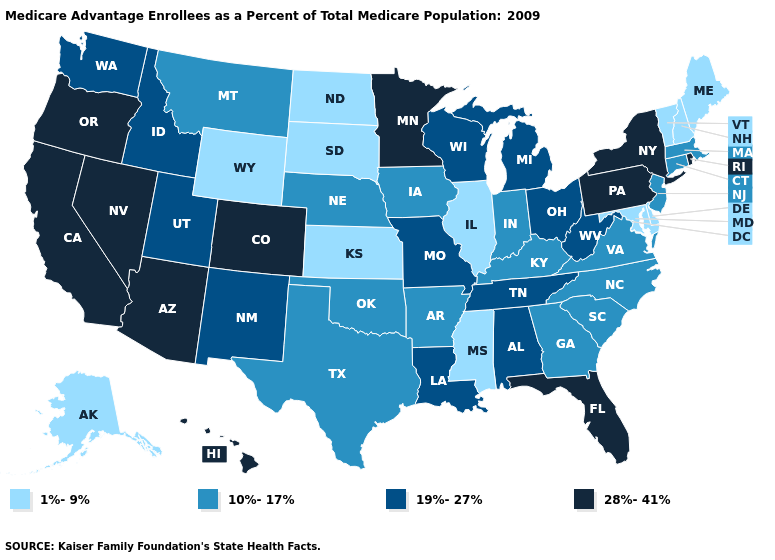Among the states that border Montana , does North Dakota have the lowest value?
Concise answer only. Yes. Is the legend a continuous bar?
Quick response, please. No. What is the lowest value in the South?
Concise answer only. 1%-9%. Among the states that border Alabama , which have the highest value?
Write a very short answer. Florida. What is the value of Indiana?
Concise answer only. 10%-17%. Which states have the highest value in the USA?
Concise answer only. Arizona, California, Colorado, Florida, Hawaii, Minnesota, Nevada, New York, Oregon, Pennsylvania, Rhode Island. What is the value of Maine?
Concise answer only. 1%-9%. Name the states that have a value in the range 10%-17%?
Concise answer only. Arkansas, Connecticut, Georgia, Iowa, Indiana, Kentucky, Massachusetts, Montana, North Carolina, Nebraska, New Jersey, Oklahoma, South Carolina, Texas, Virginia. What is the value of Iowa?
Answer briefly. 10%-17%. Is the legend a continuous bar?
Concise answer only. No. What is the highest value in the South ?
Be succinct. 28%-41%. Is the legend a continuous bar?
Answer briefly. No. What is the value of Florida?
Answer briefly. 28%-41%. Does the first symbol in the legend represent the smallest category?
Quick response, please. Yes. What is the lowest value in states that border Mississippi?
Short answer required. 10%-17%. 